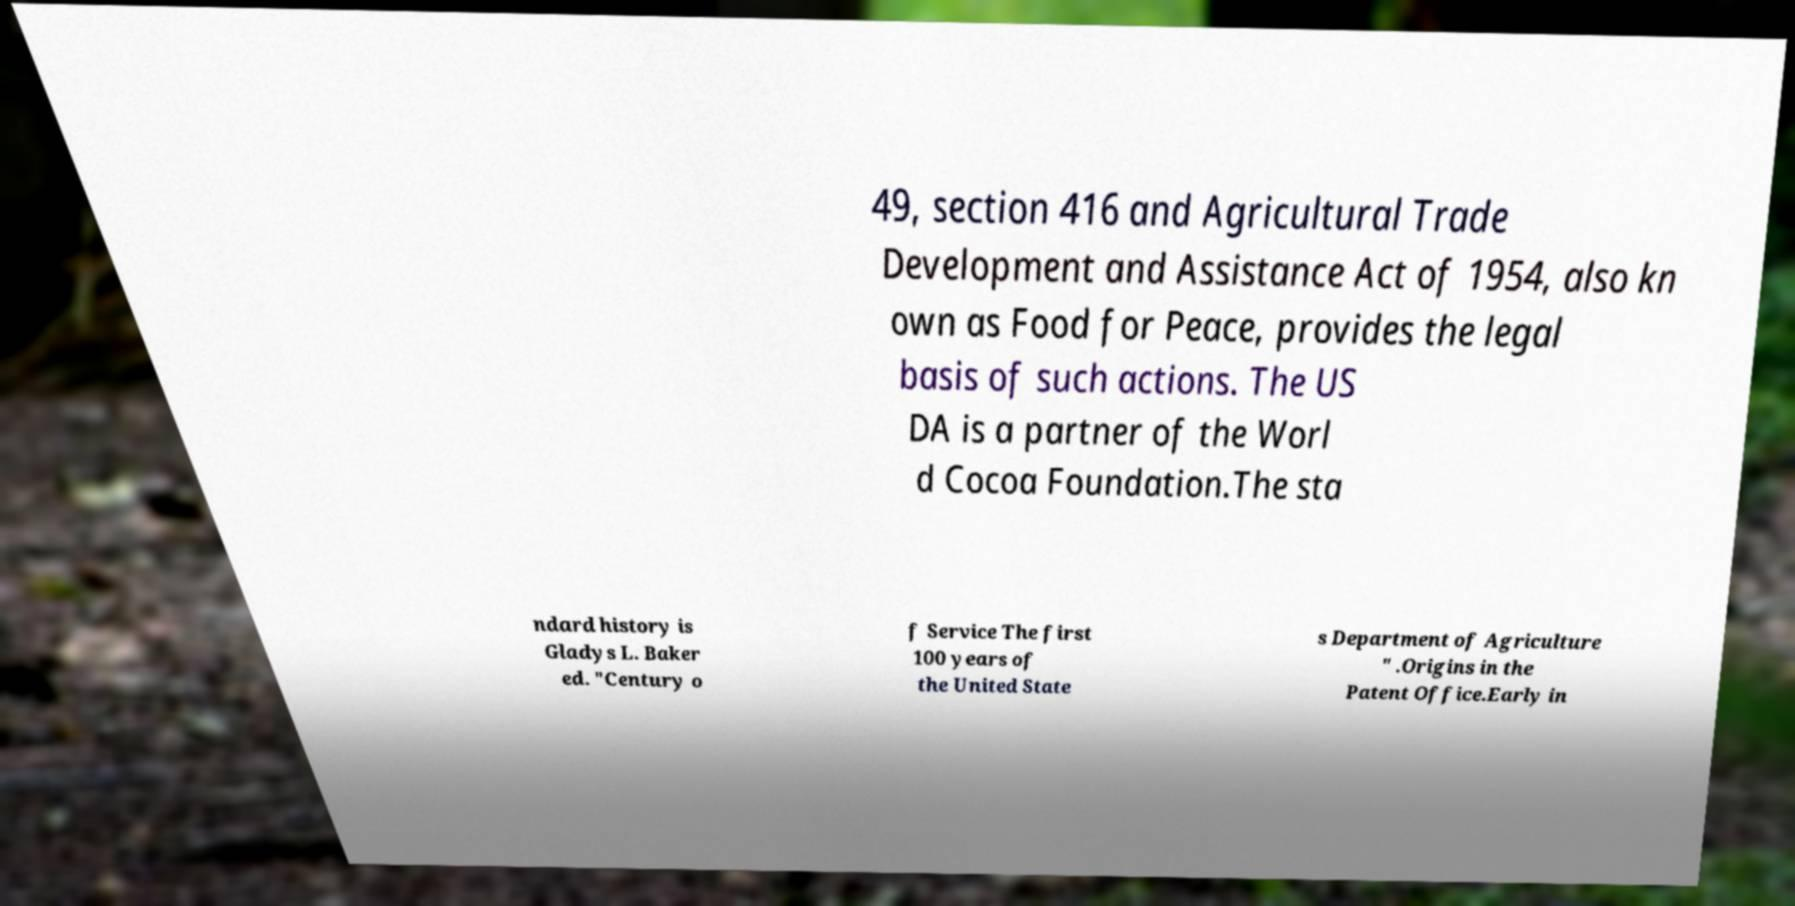I need the written content from this picture converted into text. Can you do that? 49, section 416 and Agricultural Trade Development and Assistance Act of 1954, also kn own as Food for Peace, provides the legal basis of such actions. The US DA is a partner of the Worl d Cocoa Foundation.The sta ndard history is Gladys L. Baker ed. "Century o f Service The first 100 years of the United State s Department of Agriculture " .Origins in the Patent Office.Early in 